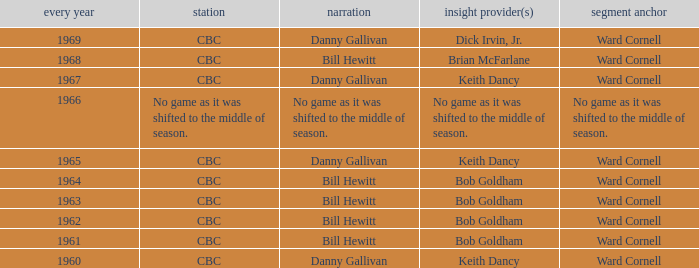Who did the play-by-play with studio host Ward Cornell and color commentator Bob Goldham? Bill Hewitt, Bill Hewitt, Bill Hewitt, Bill Hewitt. 